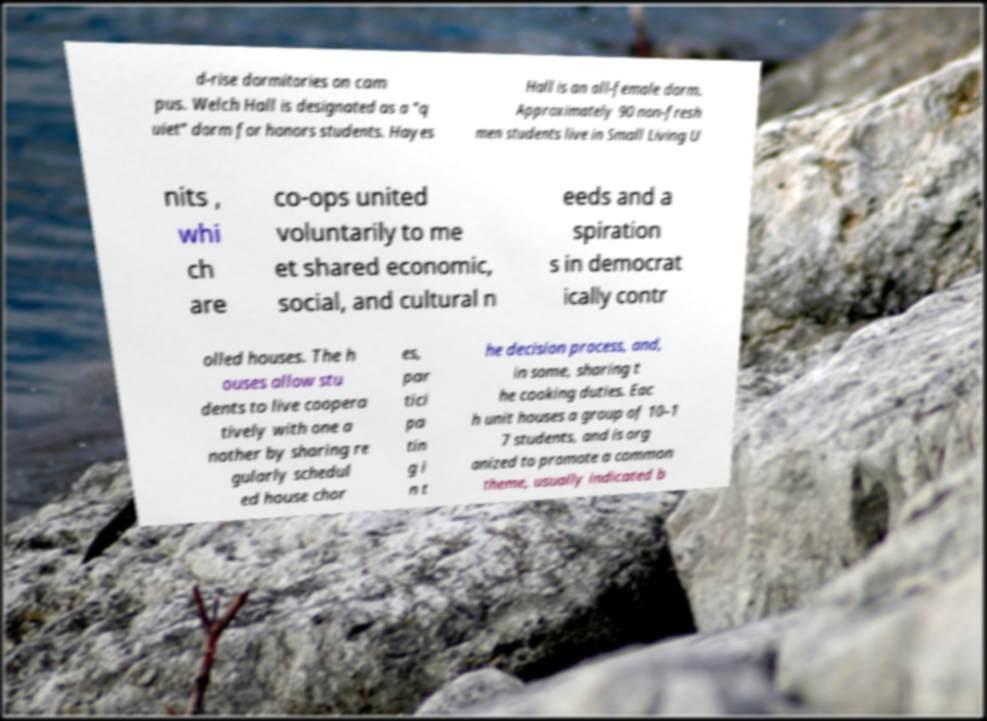What messages or text are displayed in this image? I need them in a readable, typed format. d-rise dormitories on cam pus. Welch Hall is designated as a "q uiet" dorm for honors students. Hayes Hall is an all-female dorm. Approximately 90 non-fresh men students live in Small Living U nits , whi ch are co-ops united voluntarily to me et shared economic, social, and cultural n eeds and a spiration s in democrat ically contr olled houses. The h ouses allow stu dents to live coopera tively with one a nother by sharing re gularly schedul ed house chor es, par tici pa tin g i n t he decision process, and, in some, sharing t he cooking duties. Eac h unit houses a group of 10–1 7 students, and is org anized to promote a common theme, usually indicated b 